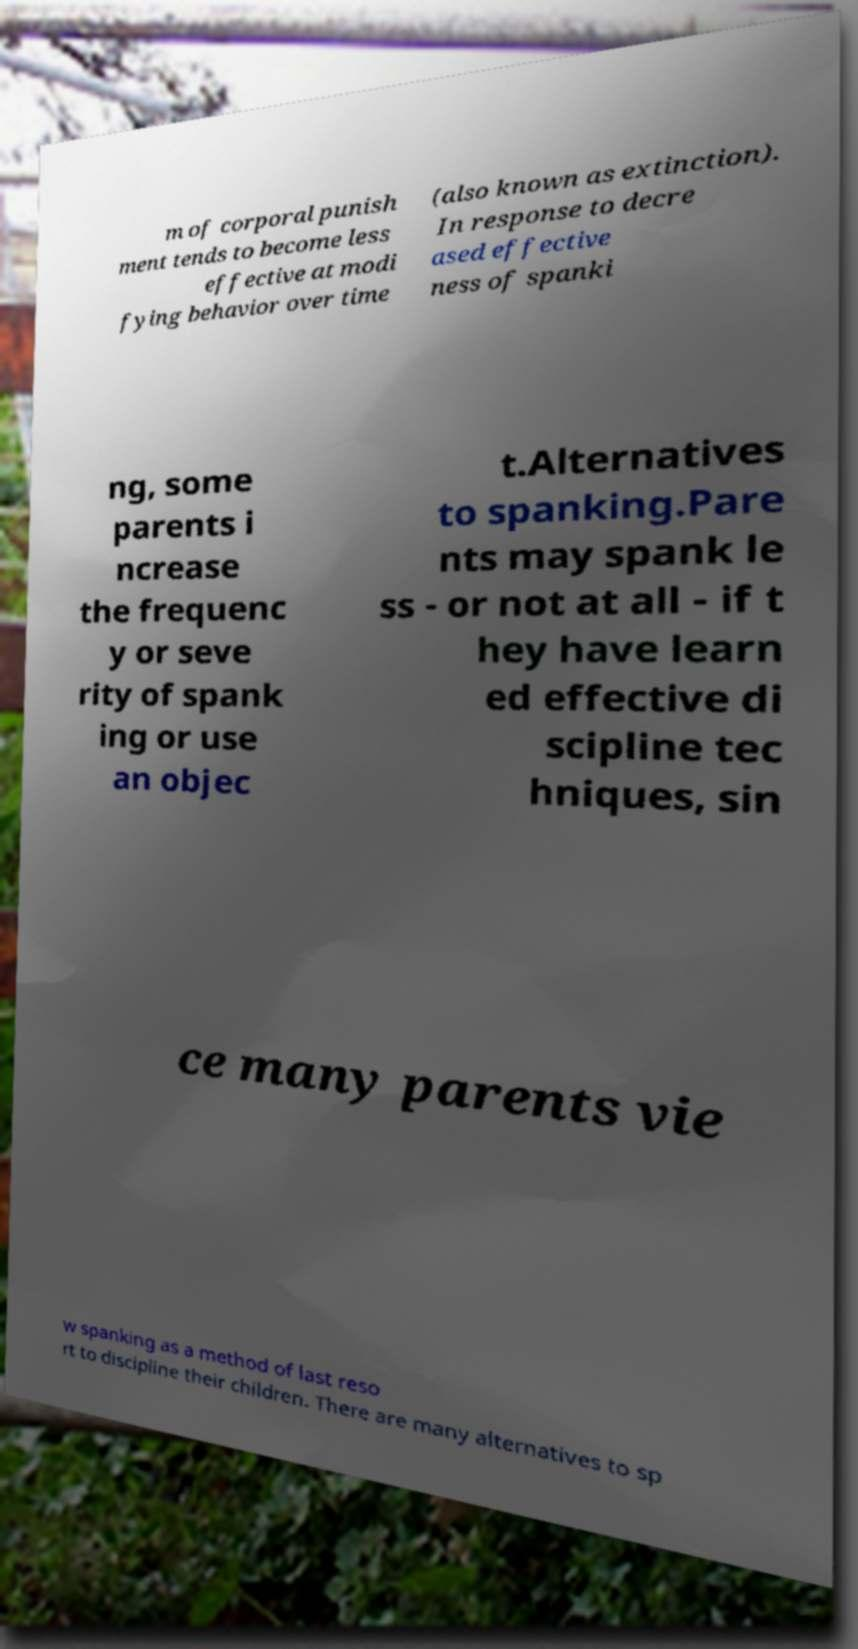There's text embedded in this image that I need extracted. Can you transcribe it verbatim? m of corporal punish ment tends to become less effective at modi fying behavior over time (also known as extinction). In response to decre ased effective ness of spanki ng, some parents i ncrease the frequenc y or seve rity of spank ing or use an objec t.Alternatives to spanking.Pare nts may spank le ss - or not at all - if t hey have learn ed effective di scipline tec hniques, sin ce many parents vie w spanking as a method of last reso rt to discipline their children. There are many alternatives to sp 